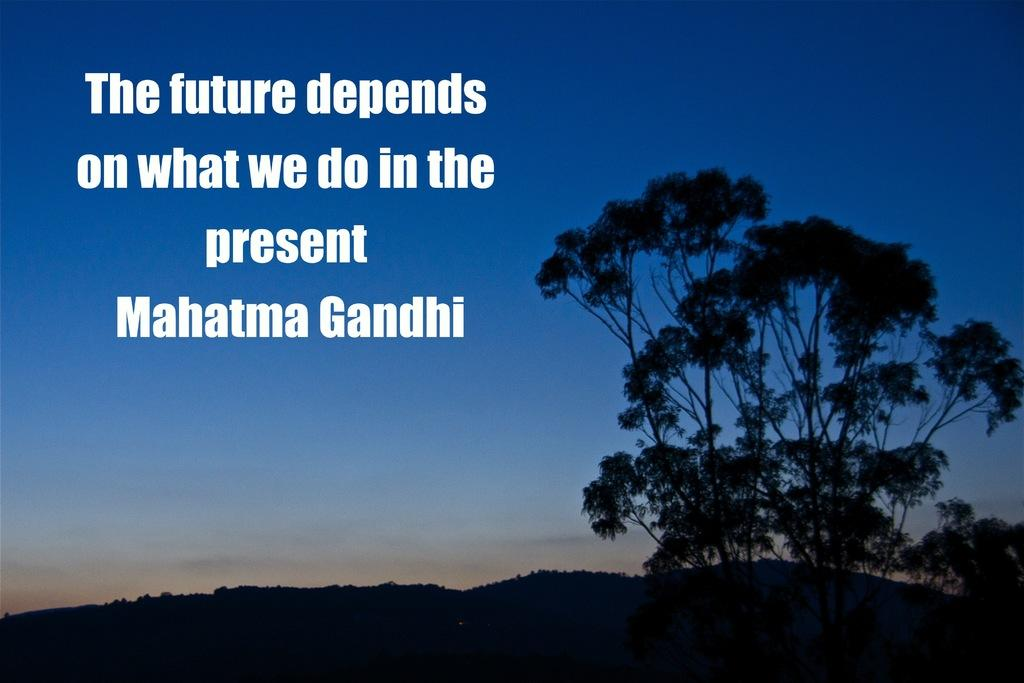What type of natural features can be seen in the image? There are trees and mountains in the image. What part of the natural environment is visible in the image? The sky is visible in the image. What else can be seen in the foreground of the image? There is some text in the foreground of the image. What type of bell can be heard ringing in the image? There is no bell present in the image, and therefore no sound can be heard. 